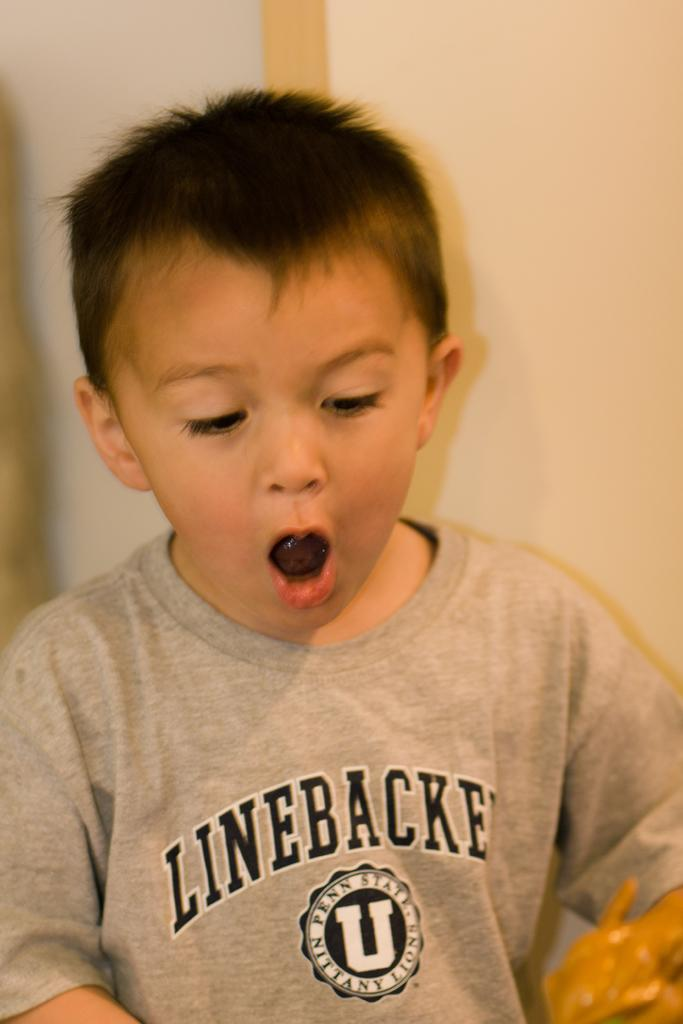What is the main subject of the picture? The main subject of the picture is a kid. What is the kid wearing in the image? The kid is wearing a t-shirt. Can you describe the kid's posture in the image? The kid appears to be standing. What can be seen in the background of the image? There is an object in the background that resembles a wall. What type of butter is being exchanged between the kid and the wall in the image? There is no butter or exchange present in the image; it features a kid standing in front of an object that resembles a wall. 